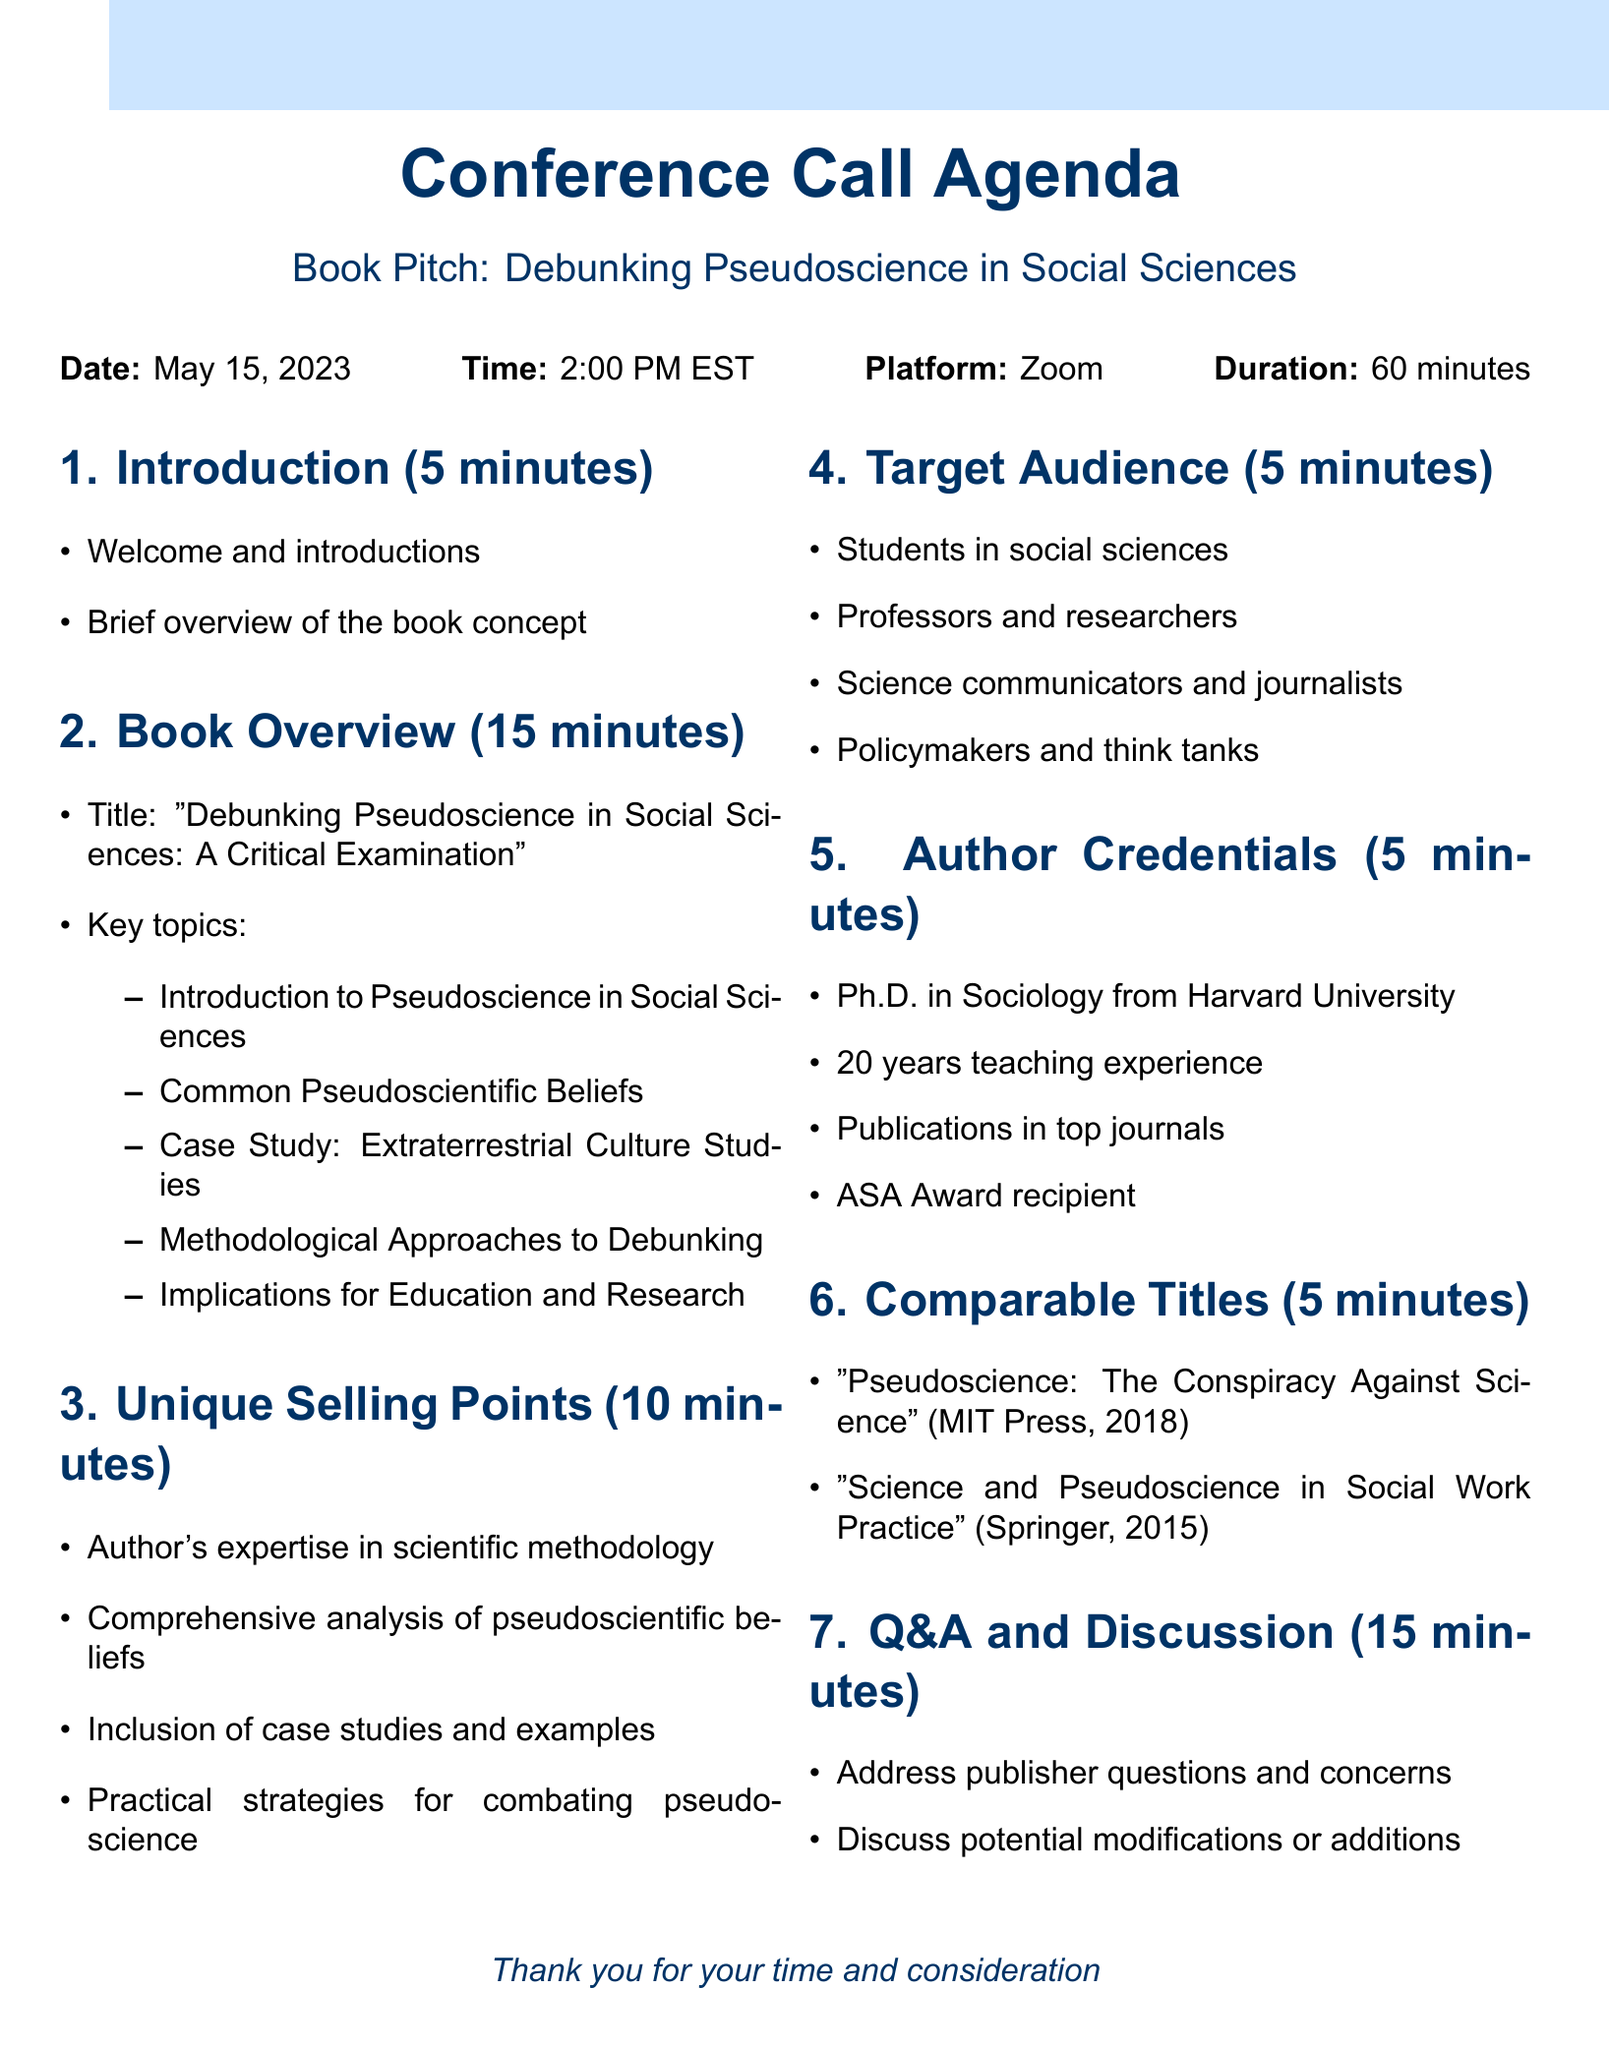What is the date of the conference call? The date is specified in the document under conference call details, which is May 15, 2023.
Answer: May 15, 2023 What is the duration of the call? The duration is listed in the conference call details, which states that the call will last for 60 minutes.
Answer: 60 minutes What are the target publishers for the book? The target publishers are provided in a list within the document, which includes Oxford University Press, SAGE Publications, Routledge, and Wiley-Blackwell.
Answer: Oxford University Press, SAGE Publications, Routledge, Wiley-Blackwell Which case study is included in the book? The document outlines one specific case study in the key topics section titled "Extraterrestrial Culture Studies."
Answer: Extraterrestrial Culture Studies How long is the Q&A session scheduled for? The agenda specifies that the Q&A and Discussion section is allotted 15 minutes in the conference call.
Answer: 15 minutes What is one unique selling point of the book? The unique selling points are listed, one of which is the author's expertise in scientific methodology.
Answer: Author's expertise in scientific methodology What educational background does the author have? The document mentions the author's credentials, stating they have a Ph.D. in Sociology from Harvard University.
Answer: Ph.D. in Sociology from Harvard University What is one comparable title mentioned in the document? The document lists comparable titles, including "Pseudoscience: The Conspiracy Against Science."
Answer: Pseudoscience: The Conspiracy Against Science Who are the target audiences for the book? The target audiences are categorized in the document, which mentions undergraduate and graduate students in social sciences.
Answer: Undergraduate and graduate students in social sciences 